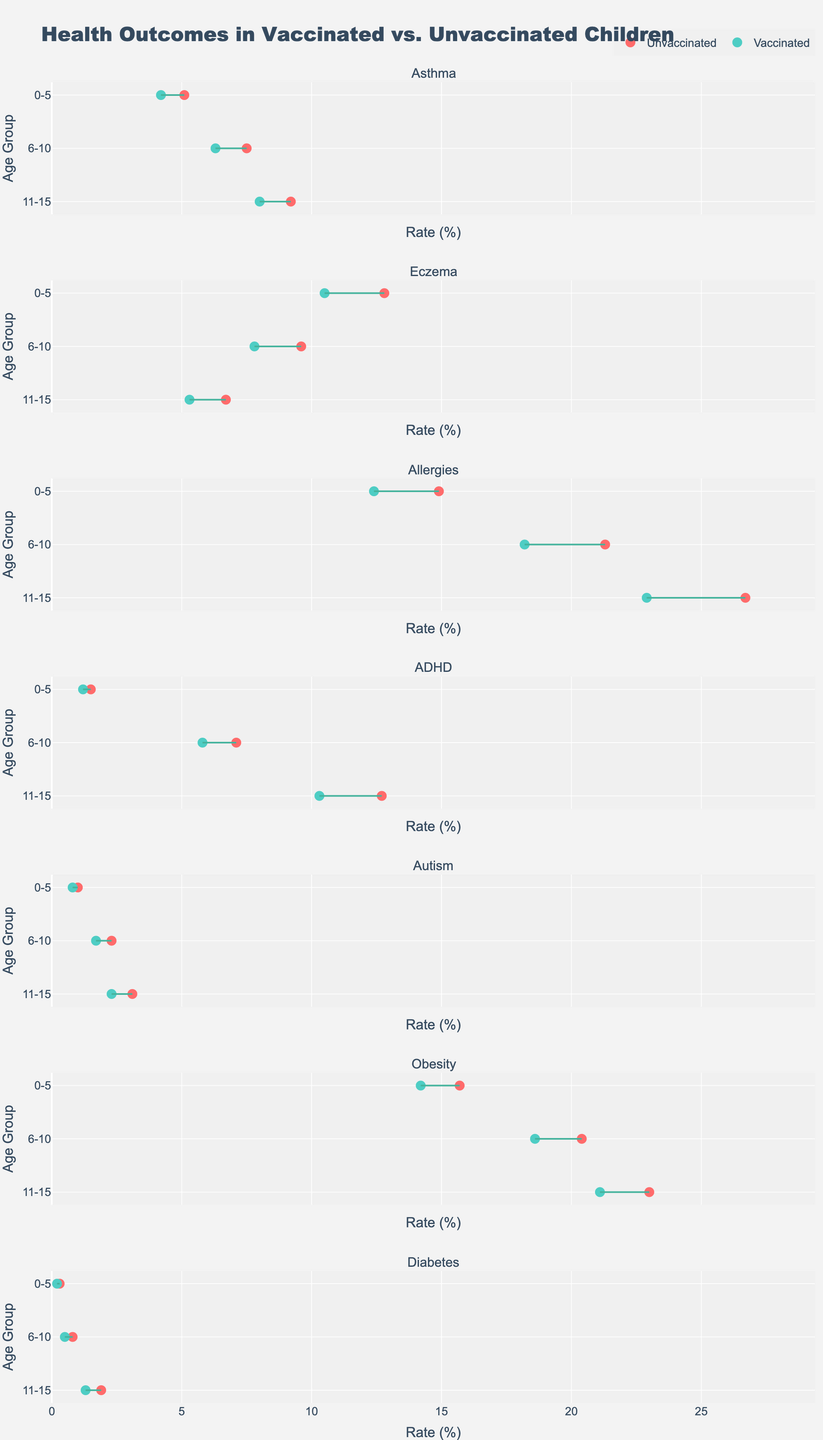What's the title of the figure? The title of the figure is typically displayed at the top and summarizes the content. In this plot, it states "Health Outcomes in Vaccinated vs. Unvaccinated Children," giving an overview of what the plot represents.
Answer: Health Outcomes in Vaccinated vs. Unvaccinated Children What is the color used for vaccinated children in the figure? The plot uses color-coding to distinguish between groups. For vaccinated children, the color used is a shade of turquoise.
Answer: Turquoise Which age group has the highest rate of ADHD among unvaccinated children? To determine this, look at the segment for ADHD and find the highest point on the x-axis for the unvaccinated group across age groups. The highest rate is observed in the 11-15 age group.
Answer: 11-15 What is the difference in the rate of obesity between vaccinated and unvaccinated children in the 6-10 age group? Find the obesity rates for the vaccinated and unvaccinated children in the 6-10 age group. The rates are 18.6% (vaccinated) and 20.4% (unvaccinated). The difference is 20.4% - 18.6%.
Answer: 1.8% Which health outcome shows the smallest difference in rates between vaccinated and unvaccinated children in the 0-5 age group? Identify the health outcomes where the differences between the vaccinated and unvaccinated rates are smallest for the 0-5 age group. Compare each health outcome and find that autism has a difference of 0.2% (1.0% - 0.8%).
Answer: Autism For which health outcome and age group do vaccinated children have a rate greater than 20%? Check the rates of all health outcomes for vaccinated children and identify any rate that exceeds 20%. The only instance is allergies in the 11-15 age group, with a rate of 22.9%.
Answer: Allergies, 11-15 How does the rate of eczema in vaccinated children in the 6-10 age group compare to unvaccinated children? Compare the rates for eczema in the 6-10 age group between vaccinated and unvaccinated children. The vaccinated rate is 7.8%, and the unvaccinated rate is 9.6%. Vaccinated children have a lower rate.
Answer: Lower Which health outcome shows a consistent increase in rates with age for both vaccinated and unvaccinated children? Examine the rates across age groups for all health outcomes and see which ones steadily increase. ADHD shows an increasing trend for both vaccinated and unvaccinated children across age groups.
Answer: ADHD 